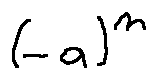<formula> <loc_0><loc_0><loc_500><loc_500>( - a ) ^ { n }</formula> 